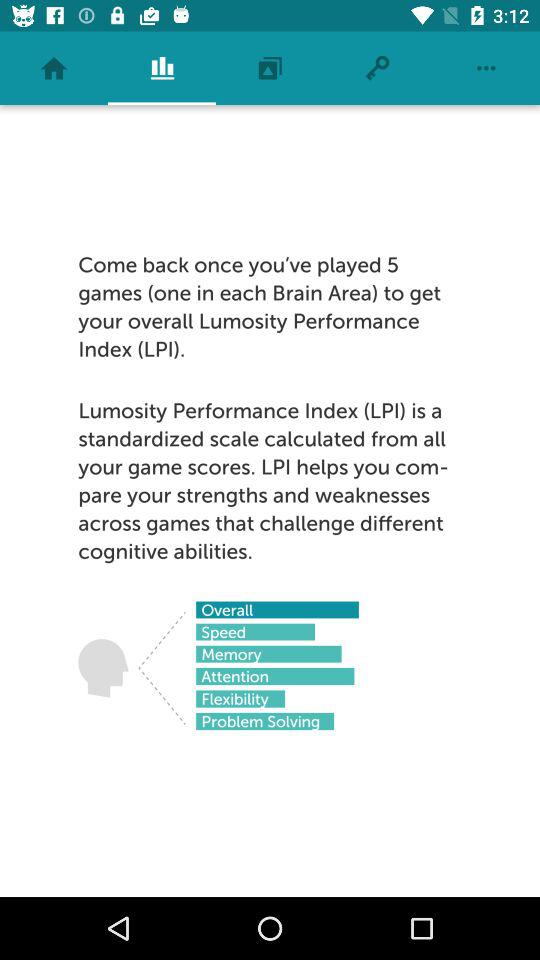How many games do you need to play to get your LPI?
Answer the question using a single word or phrase. 5 